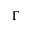Convert formula to latex. <formula><loc_0><loc_0><loc_500><loc_500>\Gamma</formula> 